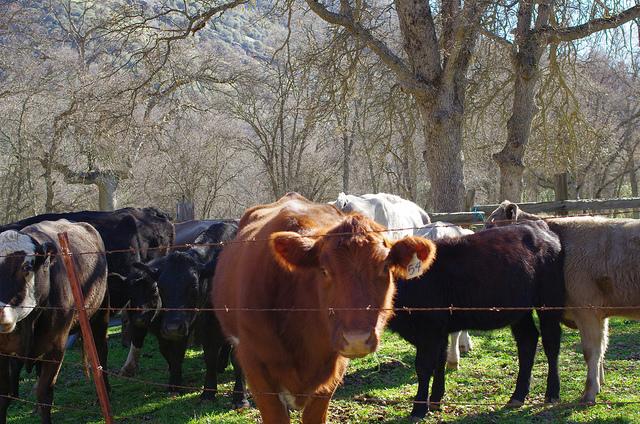Are all of the animals the same color?
Write a very short answer. No. What kind of fencing wire is this?
Keep it brief. Barbed wire. Are all the cows facing forward?
Quick response, please. No. 